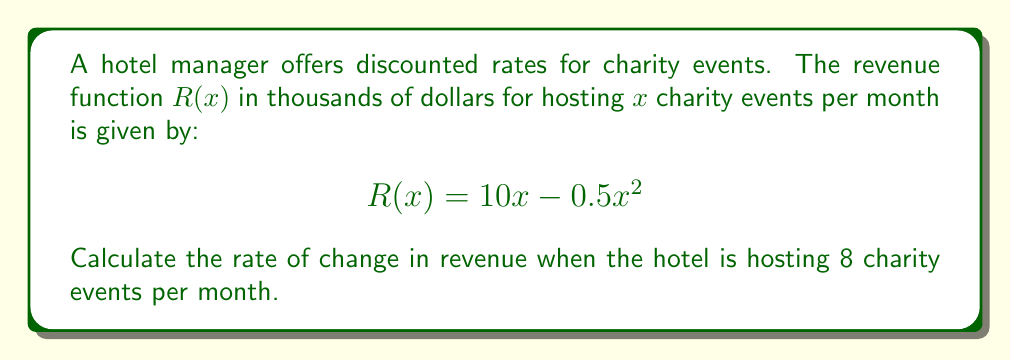Give your solution to this math problem. To find the rate of change in revenue, we need to calculate the derivative of the revenue function $R(x)$ and then evaluate it at $x = 8$.

Step 1: Find the derivative of $R(x)$
$$R(x) = 10x - 0.5x^2$$
$$R'(x) = 10 - x$$

Step 2: Evaluate $R'(x)$ at $x = 8$
$$R'(8) = 10 - 8 = 2$$

Step 3: Interpret the result
The rate of change in revenue when hosting 8 charity events per month is 2 thousand dollars per event. This means that if the hotel increases the number of charity events from 8 to 9, the revenue would increase by approximately $2,000.

Note: The negative coefficient in the quadratic term of the original function indicates that there's a maximum revenue point. After this point, hosting more events would actually decrease revenue due to the discounted rates.
Answer: $2,000 per event 